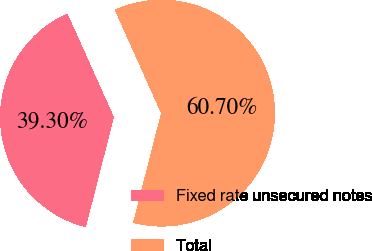Convert chart. <chart><loc_0><loc_0><loc_500><loc_500><pie_chart><fcel>Fixed rate unsecured notes<fcel>Total<nl><fcel>39.3%<fcel>60.7%<nl></chart> 